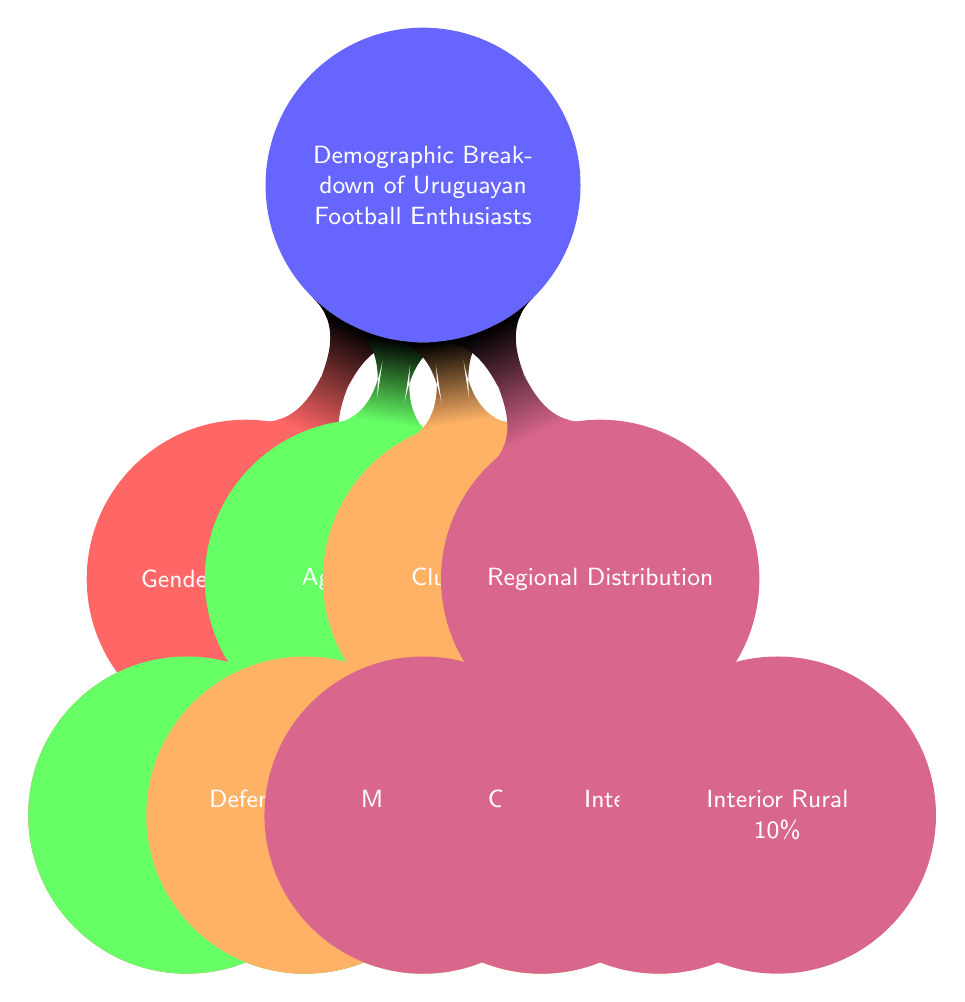What percentage of Uruguayan football enthusiasts are Male? The diagram shows the Gender Distribution node, which breaks down gender percentages. Underneath, it states that Male represents 60% of Uruguayan football enthusiasts.
Answer: 60% What age group has the highest percentage of football enthusiasts? Looking at the Age Groups node, we see that the age group 18-25 has 30%, which is higher than the others: 26-35 (25%), 36-50 (25%), and Above 50 (20%).
Answer: 18-25 How many percent of fans support Defensor Sporting? The Club Support node lists the percentage of fans supporting various clubs, which states that 15% support Defensor Sporting.
Answer: 15% Which region has the lowest percentage of football enthusiasts? In the Regional Distribution node, it shows four regions with percentages. The lowest is Interior Rural, having 10%, compared to Montevideo (40%), Canelones (20%), and Interior Urban (30%).
Answer: Interior Rural What is the combined percentage of enthusiasts aged 26 and older? By summing age groups from 26-35 (25%), 36-50 (25%), and Above 50 (20%), we find the total: 25 + 25 + 20 equals 70%.
Answer: 70% What is the ratio of female to male football enthusiasts? The Gender Distribution shows Male at 60% and Female at 40%. Thus, the ratio is 40 to 60, which can be simplified to 2 to 3.
Answer: 2 to 3 What percentage of fans come from Montevideo? The diagram under Regional Distribution states that 40% of football enthusiasts are from Montevideo.
Answer: 40% How many fans support either Nacional or Peñarol? According to the Club Support node, Peñarol has 40%, and Nacional has 35%. The total is 40 + 35, which equals 75%.
Answer: 75% 